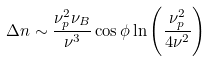Convert formula to latex. <formula><loc_0><loc_0><loc_500><loc_500>\Delta n \sim \frac { \nu _ { p } ^ { 2 } \nu _ { B } } { \nu ^ { 3 } } \cos \phi \ln \left ( \frac { \nu _ { p } ^ { 2 } } { 4 \nu ^ { 2 } } \right )</formula> 